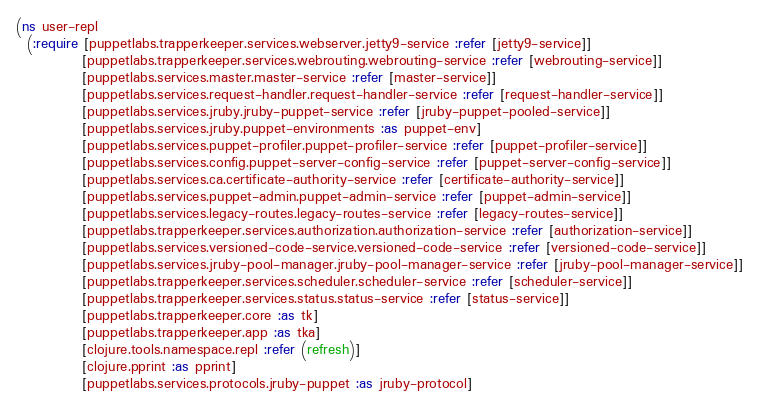<code> <loc_0><loc_0><loc_500><loc_500><_Clojure_>(ns user-repl
  (:require [puppetlabs.trapperkeeper.services.webserver.jetty9-service :refer [jetty9-service]]
            [puppetlabs.trapperkeeper.services.webrouting.webrouting-service :refer [webrouting-service]]
            [puppetlabs.services.master.master-service :refer [master-service]]
            [puppetlabs.services.request-handler.request-handler-service :refer [request-handler-service]]
            [puppetlabs.services.jruby.jruby-puppet-service :refer [jruby-puppet-pooled-service]]
            [puppetlabs.services.jruby.puppet-environments :as puppet-env]
            [puppetlabs.services.puppet-profiler.puppet-profiler-service :refer [puppet-profiler-service]]
            [puppetlabs.services.config.puppet-server-config-service :refer [puppet-server-config-service]]
            [puppetlabs.services.ca.certificate-authority-service :refer [certificate-authority-service]]
            [puppetlabs.services.puppet-admin.puppet-admin-service :refer [puppet-admin-service]]
            [puppetlabs.services.legacy-routes.legacy-routes-service :refer [legacy-routes-service]]
            [puppetlabs.trapperkeeper.services.authorization.authorization-service :refer [authorization-service]]
            [puppetlabs.services.versioned-code-service.versioned-code-service :refer [versioned-code-service]]
            [puppetlabs.services.jruby-pool-manager.jruby-pool-manager-service :refer [jruby-pool-manager-service]]
            [puppetlabs.trapperkeeper.services.scheduler.scheduler-service :refer [scheduler-service]]
            [puppetlabs.trapperkeeper.services.status.status-service :refer [status-service]]
            [puppetlabs.trapperkeeper.core :as tk]
            [puppetlabs.trapperkeeper.app :as tka]
            [clojure.tools.namespace.repl :refer (refresh)]
            [clojure.pprint :as pprint]
            [puppetlabs.services.protocols.jruby-puppet :as jruby-protocol]</code> 